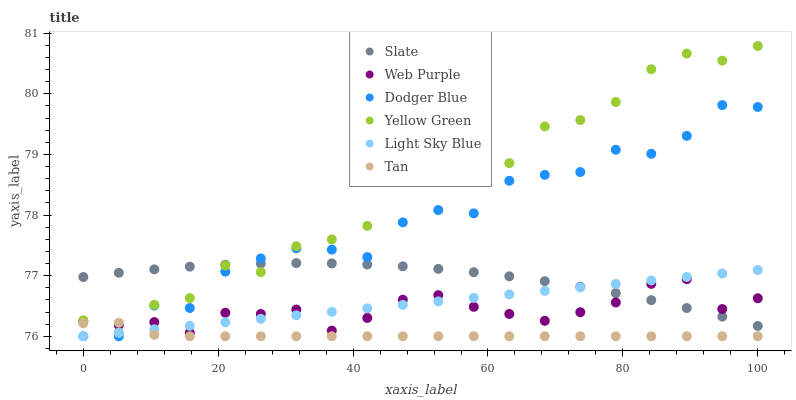Does Tan have the minimum area under the curve?
Answer yes or no. Yes. Does Yellow Green have the maximum area under the curve?
Answer yes or no. Yes. Does Slate have the minimum area under the curve?
Answer yes or no. No. Does Slate have the maximum area under the curve?
Answer yes or no. No. Is Light Sky Blue the smoothest?
Answer yes or no. Yes. Is Yellow Green the roughest?
Answer yes or no. Yes. Is Slate the smoothest?
Answer yes or no. No. Is Slate the roughest?
Answer yes or no. No. Does Light Sky Blue have the lowest value?
Answer yes or no. Yes. Does Web Purple have the lowest value?
Answer yes or no. No. Does Yellow Green have the highest value?
Answer yes or no. Yes. Does Slate have the highest value?
Answer yes or no. No. Is Tan less than Slate?
Answer yes or no. Yes. Is Yellow Green greater than Light Sky Blue?
Answer yes or no. Yes. Does Tan intersect Dodger Blue?
Answer yes or no. Yes. Is Tan less than Dodger Blue?
Answer yes or no. No. Is Tan greater than Dodger Blue?
Answer yes or no. No. Does Tan intersect Slate?
Answer yes or no. No. 